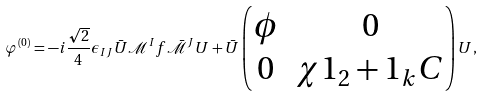<formula> <loc_0><loc_0><loc_500><loc_500>\varphi ^ { ( 0 ) } = - i \frac { \sqrt { 2 } } { 4 } \epsilon _ { I J } \bar { U } \mathcal { M } ^ { I } f \bar { \mathcal { M } } ^ { J } U + \bar { U } \begin{pmatrix} \phi & 0 \\ 0 & \chi 1 _ { 2 } + 1 _ { k } C \end{pmatrix} U ,</formula> 